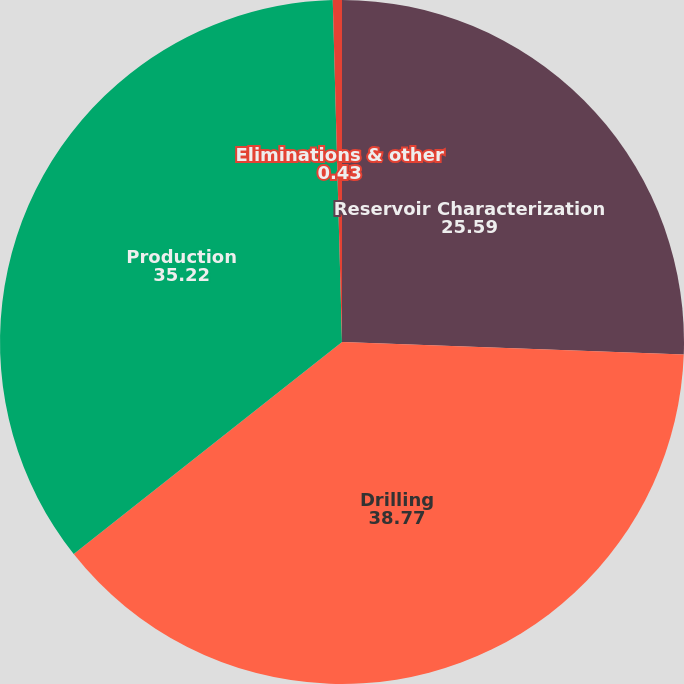Convert chart to OTSL. <chart><loc_0><loc_0><loc_500><loc_500><pie_chart><fcel>Reservoir Characterization<fcel>Drilling<fcel>Production<fcel>Eliminations & other<nl><fcel>25.59%<fcel>38.77%<fcel>35.22%<fcel>0.43%<nl></chart> 